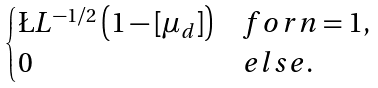<formula> <loc_0><loc_0><loc_500><loc_500>\begin{cases} \L L ^ { - 1 / 2 } \left ( 1 - [ \mu _ { d } ] \right ) & f o r n = 1 , \\ 0 & e l s e . \end{cases}</formula> 